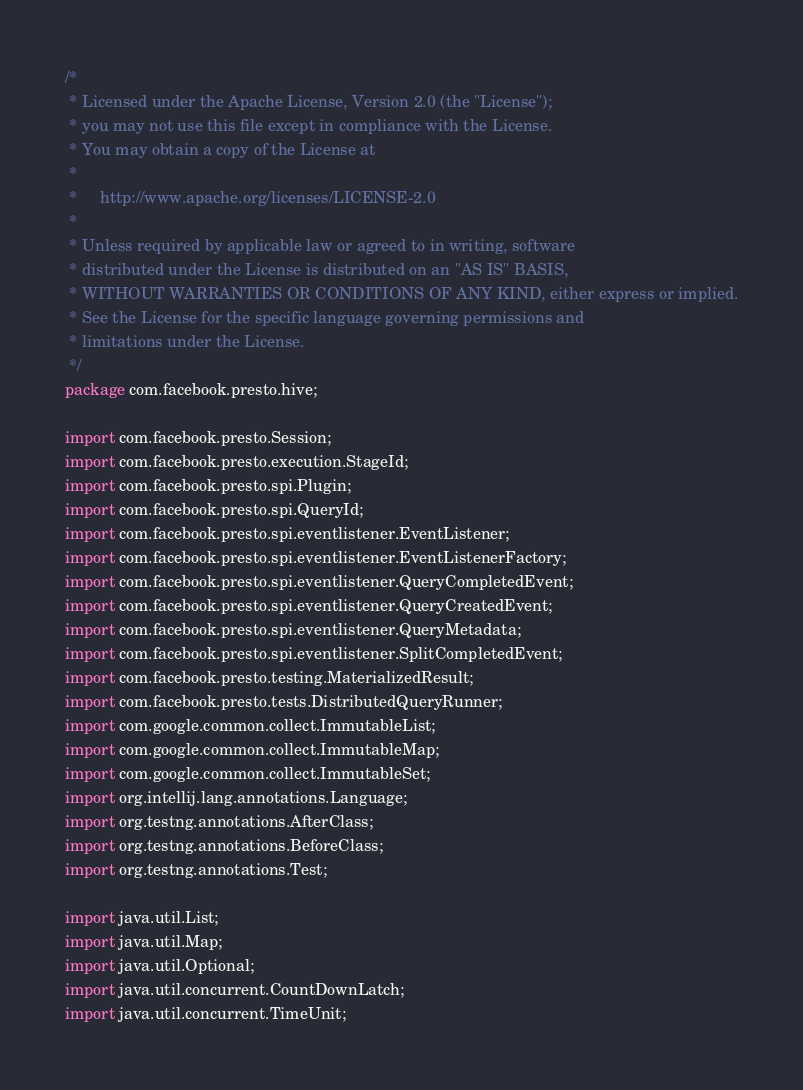<code> <loc_0><loc_0><loc_500><loc_500><_Java_>/*
 * Licensed under the Apache License, Version 2.0 (the "License");
 * you may not use this file except in compliance with the License.
 * You may obtain a copy of the License at
 *
 *     http://www.apache.org/licenses/LICENSE-2.0
 *
 * Unless required by applicable law or agreed to in writing, software
 * distributed under the License is distributed on an "AS IS" BASIS,
 * WITHOUT WARRANTIES OR CONDITIONS OF ANY KIND, either express or implied.
 * See the License for the specific language governing permissions and
 * limitations under the License.
 */
package com.facebook.presto.hive;

import com.facebook.presto.Session;
import com.facebook.presto.execution.StageId;
import com.facebook.presto.spi.Plugin;
import com.facebook.presto.spi.QueryId;
import com.facebook.presto.spi.eventlistener.EventListener;
import com.facebook.presto.spi.eventlistener.EventListenerFactory;
import com.facebook.presto.spi.eventlistener.QueryCompletedEvent;
import com.facebook.presto.spi.eventlistener.QueryCreatedEvent;
import com.facebook.presto.spi.eventlistener.QueryMetadata;
import com.facebook.presto.spi.eventlistener.SplitCompletedEvent;
import com.facebook.presto.testing.MaterializedResult;
import com.facebook.presto.tests.DistributedQueryRunner;
import com.google.common.collect.ImmutableList;
import com.google.common.collect.ImmutableMap;
import com.google.common.collect.ImmutableSet;
import org.intellij.lang.annotations.Language;
import org.testng.annotations.AfterClass;
import org.testng.annotations.BeforeClass;
import org.testng.annotations.Test;

import java.util.List;
import java.util.Map;
import java.util.Optional;
import java.util.concurrent.CountDownLatch;
import java.util.concurrent.TimeUnit;
</code> 